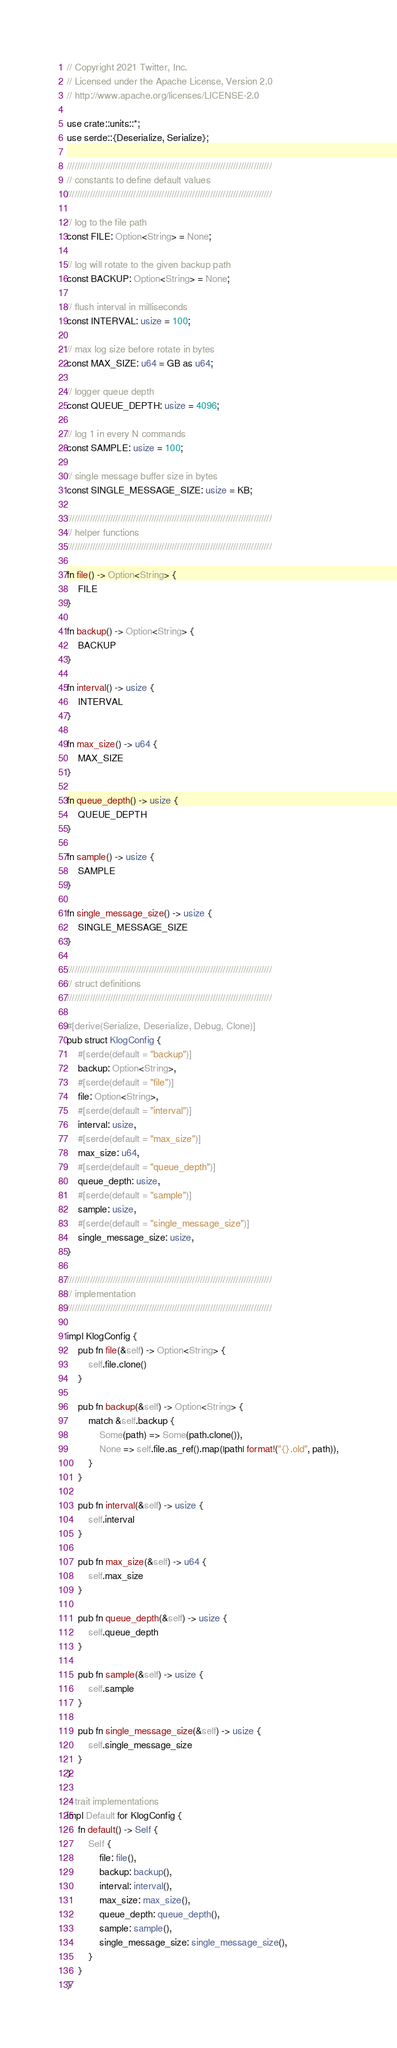Convert code to text. <code><loc_0><loc_0><loc_500><loc_500><_Rust_>// Copyright 2021 Twitter, Inc.
// Licensed under the Apache License, Version 2.0
// http://www.apache.org/licenses/LICENSE-2.0

use crate::units::*;
use serde::{Deserialize, Serialize};

////////////////////////////////////////////////////////////////////////////////
// constants to define default values
////////////////////////////////////////////////////////////////////////////////

// log to the file path
const FILE: Option<String> = None;

// log will rotate to the given backup path
const BACKUP: Option<String> = None;

// flush interval in milliseconds
const INTERVAL: usize = 100;

// max log size before rotate in bytes
const MAX_SIZE: u64 = GB as u64;

// logger queue depth
const QUEUE_DEPTH: usize = 4096;

// log 1 in every N commands
const SAMPLE: usize = 100;

// single message buffer size in bytes
const SINGLE_MESSAGE_SIZE: usize = KB;

////////////////////////////////////////////////////////////////////////////////
// helper functions
////////////////////////////////////////////////////////////////////////////////

fn file() -> Option<String> {
    FILE
}

fn backup() -> Option<String> {
    BACKUP
}

fn interval() -> usize {
    INTERVAL
}

fn max_size() -> u64 {
    MAX_SIZE
}

fn queue_depth() -> usize {
    QUEUE_DEPTH
}

fn sample() -> usize {
    SAMPLE
}

fn single_message_size() -> usize {
    SINGLE_MESSAGE_SIZE
}

////////////////////////////////////////////////////////////////////////////////
// struct definitions
////////////////////////////////////////////////////////////////////////////////

#[derive(Serialize, Deserialize, Debug, Clone)]
pub struct KlogConfig {
    #[serde(default = "backup")]
    backup: Option<String>,
    #[serde(default = "file")]
    file: Option<String>,
    #[serde(default = "interval")]
    interval: usize,
    #[serde(default = "max_size")]
    max_size: u64,
    #[serde(default = "queue_depth")]
    queue_depth: usize,
    #[serde(default = "sample")]
    sample: usize,
    #[serde(default = "single_message_size")]
    single_message_size: usize,
}

////////////////////////////////////////////////////////////////////////////////
// implementation
////////////////////////////////////////////////////////////////////////////////

impl KlogConfig {
    pub fn file(&self) -> Option<String> {
        self.file.clone()
    }

    pub fn backup(&self) -> Option<String> {
        match &self.backup {
            Some(path) => Some(path.clone()),
            None => self.file.as_ref().map(|path| format!("{}.old", path)),
        }
    }

    pub fn interval(&self) -> usize {
        self.interval
    }

    pub fn max_size(&self) -> u64 {
        self.max_size
    }

    pub fn queue_depth(&self) -> usize {
        self.queue_depth
    }

    pub fn sample(&self) -> usize {
        self.sample
    }

    pub fn single_message_size(&self) -> usize {
        self.single_message_size
    }
}

// trait implementations
impl Default for KlogConfig {
    fn default() -> Self {
        Self {
            file: file(),
            backup: backup(),
            interval: interval(),
            max_size: max_size(),
            queue_depth: queue_depth(),
            sample: sample(),
            single_message_size: single_message_size(),
        }
    }
}
</code> 